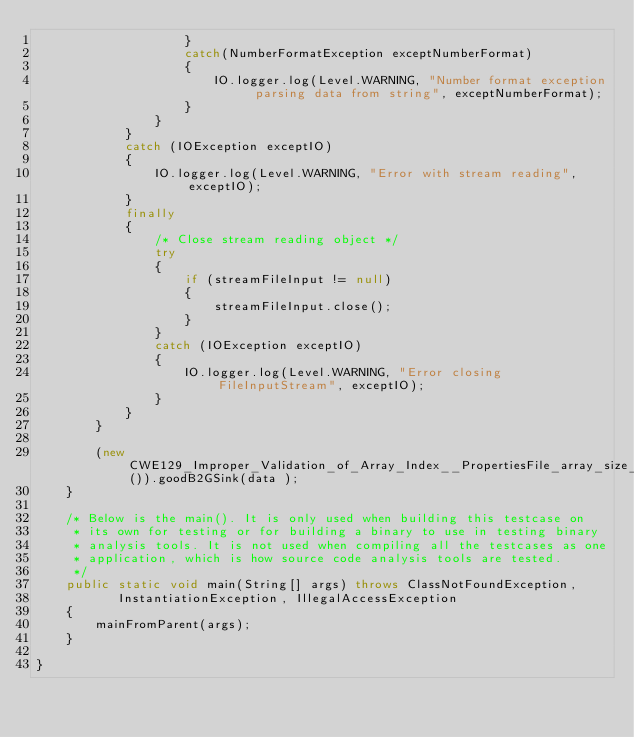Convert code to text. <code><loc_0><loc_0><loc_500><loc_500><_Java_>                    }
                    catch(NumberFormatException exceptNumberFormat)
                    {
                        IO.logger.log(Level.WARNING, "Number format exception parsing data from string", exceptNumberFormat);
                    }
                }
            }
            catch (IOException exceptIO)
            {
                IO.logger.log(Level.WARNING, "Error with stream reading", exceptIO);
            }
            finally
            {
                /* Close stream reading object */
                try
                {
                    if (streamFileInput != null)
                    {
                        streamFileInput.close();
                    }
                }
                catch (IOException exceptIO)
                {
                    IO.logger.log(Level.WARNING, "Error closing FileInputStream", exceptIO);
                }
            }
        }

        (new CWE129_Improper_Validation_of_Array_Index__PropertiesFile_array_size_53b()).goodB2GSink(data );
    }

    /* Below is the main(). It is only used when building this testcase on
     * its own for testing or for building a binary to use in testing binary
     * analysis tools. It is not used when compiling all the testcases as one
     * application, which is how source code analysis tools are tested.
     */
    public static void main(String[] args) throws ClassNotFoundException,
           InstantiationException, IllegalAccessException
    {
        mainFromParent(args);
    }

}
</code> 